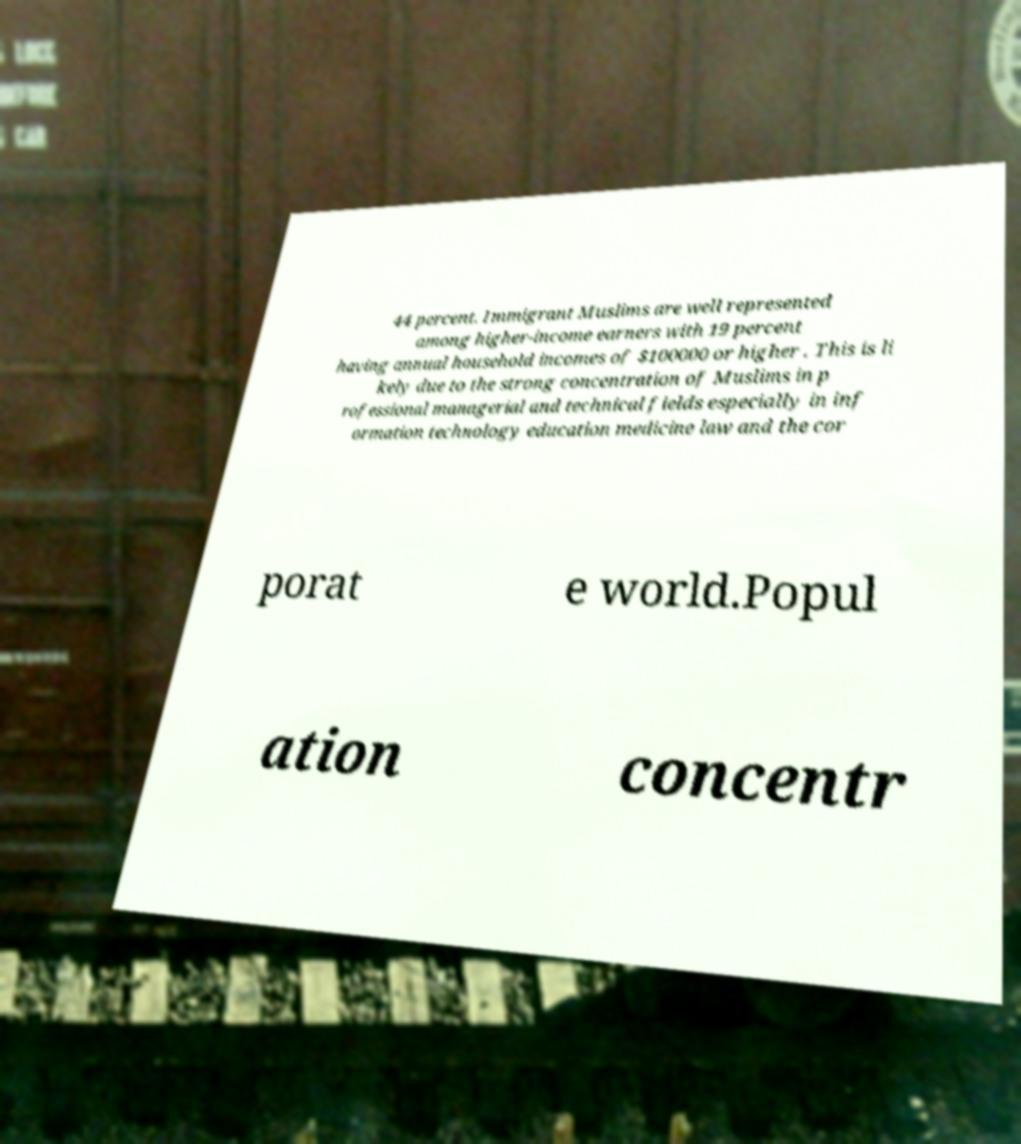Please identify and transcribe the text found in this image. 44 percent. Immigrant Muslims are well represented among higher-income earners with 19 percent having annual household incomes of $100000 or higher . This is li kely due to the strong concentration of Muslims in p rofessional managerial and technical fields especially in inf ormation technology education medicine law and the cor porat e world.Popul ation concentr 